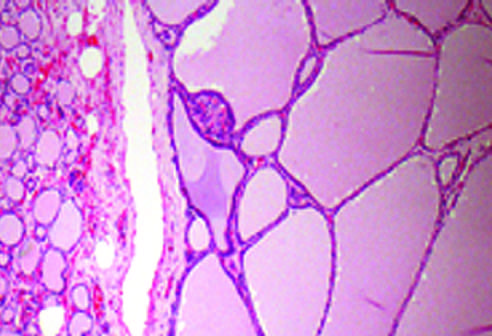do histologic features of the chancre contain abundant pink colloid within their lumina?
Answer the question using a single word or phrase. No 